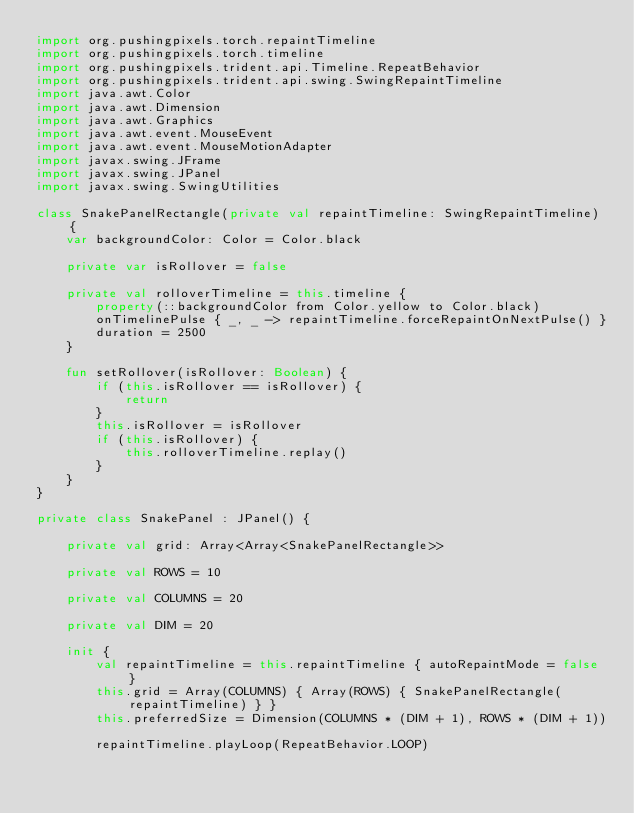<code> <loc_0><loc_0><loc_500><loc_500><_Kotlin_>import org.pushingpixels.torch.repaintTimeline
import org.pushingpixels.torch.timeline
import org.pushingpixels.trident.api.Timeline.RepeatBehavior
import org.pushingpixels.trident.api.swing.SwingRepaintTimeline
import java.awt.Color
import java.awt.Dimension
import java.awt.Graphics
import java.awt.event.MouseEvent
import java.awt.event.MouseMotionAdapter
import javax.swing.JFrame
import javax.swing.JPanel
import javax.swing.SwingUtilities

class SnakePanelRectangle(private val repaintTimeline: SwingRepaintTimeline) {
    var backgroundColor: Color = Color.black

    private var isRollover = false

    private val rolloverTimeline = this.timeline {
        property(::backgroundColor from Color.yellow to Color.black)
        onTimelinePulse { _, _ -> repaintTimeline.forceRepaintOnNextPulse() }
        duration = 2500
    }

    fun setRollover(isRollover: Boolean) {
        if (this.isRollover == isRollover) {
            return
        }
        this.isRollover = isRollover
        if (this.isRollover) {
            this.rolloverTimeline.replay()
        }
    }
}

private class SnakePanel : JPanel() {

    private val grid: Array<Array<SnakePanelRectangle>>

    private val ROWS = 10

    private val COLUMNS = 20

    private val DIM = 20

    init {
        val repaintTimeline = this.repaintTimeline { autoRepaintMode = false }
        this.grid = Array(COLUMNS) { Array(ROWS) { SnakePanelRectangle(repaintTimeline) } }
        this.preferredSize = Dimension(COLUMNS * (DIM + 1), ROWS * (DIM + 1))

        repaintTimeline.playLoop(RepeatBehavior.LOOP)
</code> 